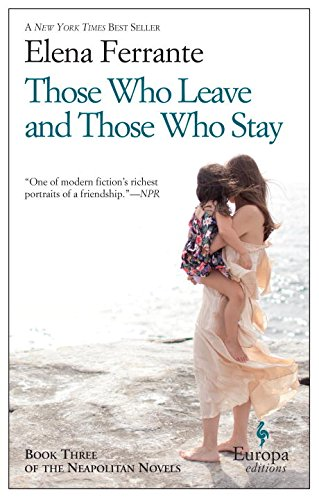How does the book depict the setting of Naples? Naples is portrayed vividly as a character in itself, reflecting the turbulent social and political climate of the era, from its charming streets to its challenging economic disparities, impacting the lives of the characters deeply. 